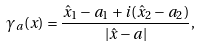<formula> <loc_0><loc_0><loc_500><loc_500>\gamma _ { a } ( x ) = \frac { \hat { x } _ { 1 } - a _ { 1 } + i ( \hat { x } _ { 2 } - a _ { 2 } ) } { \left | { \hat { x } } - { a } \right | } ,</formula> 